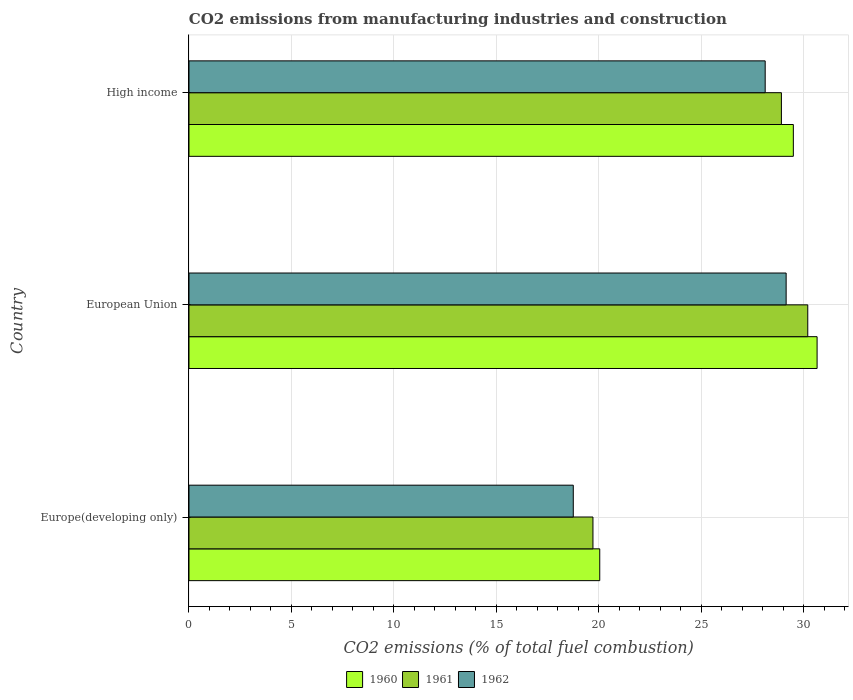How many different coloured bars are there?
Offer a very short reply. 3. How many groups of bars are there?
Keep it short and to the point. 3. How many bars are there on the 1st tick from the top?
Your response must be concise. 3. How many bars are there on the 1st tick from the bottom?
Offer a very short reply. 3. In how many cases, is the number of bars for a given country not equal to the number of legend labels?
Provide a short and direct response. 0. What is the amount of CO2 emitted in 1961 in High income?
Provide a short and direct response. 28.92. Across all countries, what is the maximum amount of CO2 emitted in 1961?
Give a very brief answer. 30.2. Across all countries, what is the minimum amount of CO2 emitted in 1960?
Your answer should be very brief. 20.05. In which country was the amount of CO2 emitted in 1961 maximum?
Keep it short and to the point. European Union. In which country was the amount of CO2 emitted in 1962 minimum?
Keep it short and to the point. Europe(developing only). What is the total amount of CO2 emitted in 1962 in the graph?
Offer a terse response. 76.03. What is the difference between the amount of CO2 emitted in 1960 in Europe(developing only) and that in High income?
Keep it short and to the point. -9.45. What is the difference between the amount of CO2 emitted in 1962 in European Union and the amount of CO2 emitted in 1961 in High income?
Provide a short and direct response. 0.23. What is the average amount of CO2 emitted in 1960 per country?
Give a very brief answer. 26.73. What is the difference between the amount of CO2 emitted in 1962 and amount of CO2 emitted in 1960 in European Union?
Make the answer very short. -1.51. What is the ratio of the amount of CO2 emitted in 1961 in Europe(developing only) to that in European Union?
Ensure brevity in your answer.  0.65. Is the difference between the amount of CO2 emitted in 1962 in European Union and High income greater than the difference between the amount of CO2 emitted in 1960 in European Union and High income?
Keep it short and to the point. No. What is the difference between the highest and the second highest amount of CO2 emitted in 1960?
Ensure brevity in your answer.  1.16. What is the difference between the highest and the lowest amount of CO2 emitted in 1961?
Offer a terse response. 10.48. What does the 2nd bar from the top in High income represents?
Give a very brief answer. 1961. Is it the case that in every country, the sum of the amount of CO2 emitted in 1962 and amount of CO2 emitted in 1961 is greater than the amount of CO2 emitted in 1960?
Make the answer very short. Yes. Are all the bars in the graph horizontal?
Ensure brevity in your answer.  Yes. How many countries are there in the graph?
Offer a terse response. 3. How are the legend labels stacked?
Provide a succinct answer. Horizontal. What is the title of the graph?
Ensure brevity in your answer.  CO2 emissions from manufacturing industries and construction. Does "1997" appear as one of the legend labels in the graph?
Your response must be concise. No. What is the label or title of the X-axis?
Your answer should be very brief. CO2 emissions (% of total fuel combustion). What is the label or title of the Y-axis?
Offer a very short reply. Country. What is the CO2 emissions (% of total fuel combustion) of 1960 in Europe(developing only)?
Give a very brief answer. 20.05. What is the CO2 emissions (% of total fuel combustion) in 1961 in Europe(developing only)?
Your answer should be very brief. 19.72. What is the CO2 emissions (% of total fuel combustion) in 1962 in Europe(developing only)?
Provide a succinct answer. 18.76. What is the CO2 emissions (% of total fuel combustion) of 1960 in European Union?
Provide a succinct answer. 30.66. What is the CO2 emissions (% of total fuel combustion) of 1961 in European Union?
Provide a short and direct response. 30.2. What is the CO2 emissions (% of total fuel combustion) in 1962 in European Union?
Your response must be concise. 29.15. What is the CO2 emissions (% of total fuel combustion) of 1960 in High income?
Make the answer very short. 29.5. What is the CO2 emissions (% of total fuel combustion) in 1961 in High income?
Offer a terse response. 28.92. What is the CO2 emissions (% of total fuel combustion) of 1962 in High income?
Provide a succinct answer. 28.12. Across all countries, what is the maximum CO2 emissions (% of total fuel combustion) in 1960?
Your answer should be compact. 30.66. Across all countries, what is the maximum CO2 emissions (% of total fuel combustion) of 1961?
Ensure brevity in your answer.  30.2. Across all countries, what is the maximum CO2 emissions (% of total fuel combustion) of 1962?
Keep it short and to the point. 29.15. Across all countries, what is the minimum CO2 emissions (% of total fuel combustion) of 1960?
Give a very brief answer. 20.05. Across all countries, what is the minimum CO2 emissions (% of total fuel combustion) of 1961?
Ensure brevity in your answer.  19.72. Across all countries, what is the minimum CO2 emissions (% of total fuel combustion) of 1962?
Give a very brief answer. 18.76. What is the total CO2 emissions (% of total fuel combustion) of 1960 in the graph?
Your answer should be compact. 80.2. What is the total CO2 emissions (% of total fuel combustion) of 1961 in the graph?
Ensure brevity in your answer.  78.83. What is the total CO2 emissions (% of total fuel combustion) in 1962 in the graph?
Keep it short and to the point. 76.03. What is the difference between the CO2 emissions (% of total fuel combustion) of 1960 in Europe(developing only) and that in European Union?
Provide a succinct answer. -10.61. What is the difference between the CO2 emissions (% of total fuel combustion) in 1961 in Europe(developing only) and that in European Union?
Your response must be concise. -10.48. What is the difference between the CO2 emissions (% of total fuel combustion) in 1962 in Europe(developing only) and that in European Union?
Your answer should be compact. -10.39. What is the difference between the CO2 emissions (% of total fuel combustion) of 1960 in Europe(developing only) and that in High income?
Make the answer very short. -9.45. What is the difference between the CO2 emissions (% of total fuel combustion) in 1961 in Europe(developing only) and that in High income?
Ensure brevity in your answer.  -9.2. What is the difference between the CO2 emissions (% of total fuel combustion) in 1962 in Europe(developing only) and that in High income?
Your answer should be very brief. -9.37. What is the difference between the CO2 emissions (% of total fuel combustion) of 1960 in European Union and that in High income?
Offer a very short reply. 1.16. What is the difference between the CO2 emissions (% of total fuel combustion) in 1961 in European Union and that in High income?
Provide a short and direct response. 1.29. What is the difference between the CO2 emissions (% of total fuel combustion) in 1962 in European Union and that in High income?
Offer a very short reply. 1.02. What is the difference between the CO2 emissions (% of total fuel combustion) of 1960 in Europe(developing only) and the CO2 emissions (% of total fuel combustion) of 1961 in European Union?
Provide a short and direct response. -10.15. What is the difference between the CO2 emissions (% of total fuel combustion) in 1960 in Europe(developing only) and the CO2 emissions (% of total fuel combustion) in 1962 in European Union?
Offer a terse response. -9.1. What is the difference between the CO2 emissions (% of total fuel combustion) in 1961 in Europe(developing only) and the CO2 emissions (% of total fuel combustion) in 1962 in European Union?
Your answer should be very brief. -9.43. What is the difference between the CO2 emissions (% of total fuel combustion) in 1960 in Europe(developing only) and the CO2 emissions (% of total fuel combustion) in 1961 in High income?
Offer a terse response. -8.87. What is the difference between the CO2 emissions (% of total fuel combustion) of 1960 in Europe(developing only) and the CO2 emissions (% of total fuel combustion) of 1962 in High income?
Your answer should be compact. -8.07. What is the difference between the CO2 emissions (% of total fuel combustion) of 1961 in Europe(developing only) and the CO2 emissions (% of total fuel combustion) of 1962 in High income?
Keep it short and to the point. -8.41. What is the difference between the CO2 emissions (% of total fuel combustion) of 1960 in European Union and the CO2 emissions (% of total fuel combustion) of 1961 in High income?
Offer a terse response. 1.74. What is the difference between the CO2 emissions (% of total fuel combustion) in 1960 in European Union and the CO2 emissions (% of total fuel combustion) in 1962 in High income?
Your answer should be compact. 2.53. What is the difference between the CO2 emissions (% of total fuel combustion) of 1961 in European Union and the CO2 emissions (% of total fuel combustion) of 1962 in High income?
Your answer should be compact. 2.08. What is the average CO2 emissions (% of total fuel combustion) of 1960 per country?
Ensure brevity in your answer.  26.73. What is the average CO2 emissions (% of total fuel combustion) of 1961 per country?
Provide a short and direct response. 26.28. What is the average CO2 emissions (% of total fuel combustion) of 1962 per country?
Provide a short and direct response. 25.34. What is the difference between the CO2 emissions (% of total fuel combustion) in 1960 and CO2 emissions (% of total fuel combustion) in 1961 in Europe(developing only)?
Your answer should be very brief. 0.33. What is the difference between the CO2 emissions (% of total fuel combustion) in 1960 and CO2 emissions (% of total fuel combustion) in 1962 in Europe(developing only)?
Your response must be concise. 1.29. What is the difference between the CO2 emissions (% of total fuel combustion) in 1961 and CO2 emissions (% of total fuel combustion) in 1962 in Europe(developing only)?
Ensure brevity in your answer.  0.96. What is the difference between the CO2 emissions (% of total fuel combustion) of 1960 and CO2 emissions (% of total fuel combustion) of 1961 in European Union?
Provide a short and direct response. 0.46. What is the difference between the CO2 emissions (% of total fuel combustion) of 1960 and CO2 emissions (% of total fuel combustion) of 1962 in European Union?
Offer a terse response. 1.51. What is the difference between the CO2 emissions (% of total fuel combustion) of 1961 and CO2 emissions (% of total fuel combustion) of 1962 in European Union?
Provide a short and direct response. 1.05. What is the difference between the CO2 emissions (% of total fuel combustion) of 1960 and CO2 emissions (% of total fuel combustion) of 1961 in High income?
Provide a succinct answer. 0.58. What is the difference between the CO2 emissions (% of total fuel combustion) in 1960 and CO2 emissions (% of total fuel combustion) in 1962 in High income?
Your response must be concise. 1.37. What is the difference between the CO2 emissions (% of total fuel combustion) in 1961 and CO2 emissions (% of total fuel combustion) in 1962 in High income?
Offer a very short reply. 0.79. What is the ratio of the CO2 emissions (% of total fuel combustion) of 1960 in Europe(developing only) to that in European Union?
Ensure brevity in your answer.  0.65. What is the ratio of the CO2 emissions (% of total fuel combustion) of 1961 in Europe(developing only) to that in European Union?
Offer a very short reply. 0.65. What is the ratio of the CO2 emissions (% of total fuel combustion) in 1962 in Europe(developing only) to that in European Union?
Provide a short and direct response. 0.64. What is the ratio of the CO2 emissions (% of total fuel combustion) of 1960 in Europe(developing only) to that in High income?
Provide a short and direct response. 0.68. What is the ratio of the CO2 emissions (% of total fuel combustion) in 1961 in Europe(developing only) to that in High income?
Your answer should be compact. 0.68. What is the ratio of the CO2 emissions (% of total fuel combustion) of 1962 in Europe(developing only) to that in High income?
Your response must be concise. 0.67. What is the ratio of the CO2 emissions (% of total fuel combustion) in 1960 in European Union to that in High income?
Your answer should be compact. 1.04. What is the ratio of the CO2 emissions (% of total fuel combustion) in 1961 in European Union to that in High income?
Your answer should be compact. 1.04. What is the ratio of the CO2 emissions (% of total fuel combustion) of 1962 in European Union to that in High income?
Your answer should be compact. 1.04. What is the difference between the highest and the second highest CO2 emissions (% of total fuel combustion) of 1960?
Provide a short and direct response. 1.16. What is the difference between the highest and the second highest CO2 emissions (% of total fuel combustion) in 1961?
Provide a succinct answer. 1.29. What is the difference between the highest and the second highest CO2 emissions (% of total fuel combustion) in 1962?
Give a very brief answer. 1.02. What is the difference between the highest and the lowest CO2 emissions (% of total fuel combustion) in 1960?
Your answer should be very brief. 10.61. What is the difference between the highest and the lowest CO2 emissions (% of total fuel combustion) in 1961?
Provide a short and direct response. 10.48. What is the difference between the highest and the lowest CO2 emissions (% of total fuel combustion) in 1962?
Your response must be concise. 10.39. 